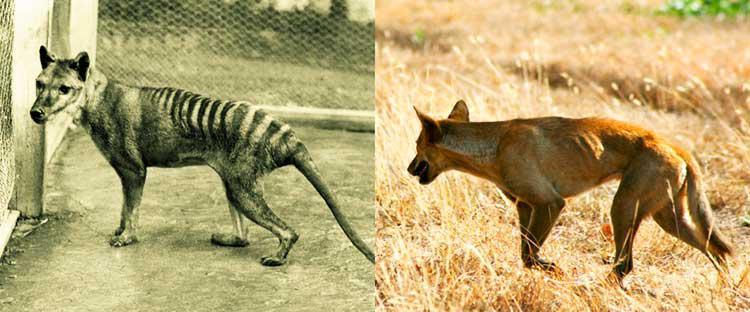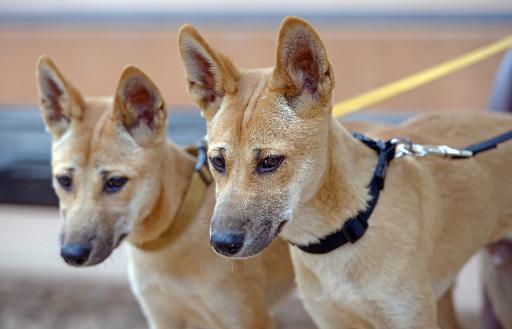The first image is the image on the left, the second image is the image on the right. For the images shown, is this caption "At least one image features multiple dogs." true? Answer yes or no. Yes. 